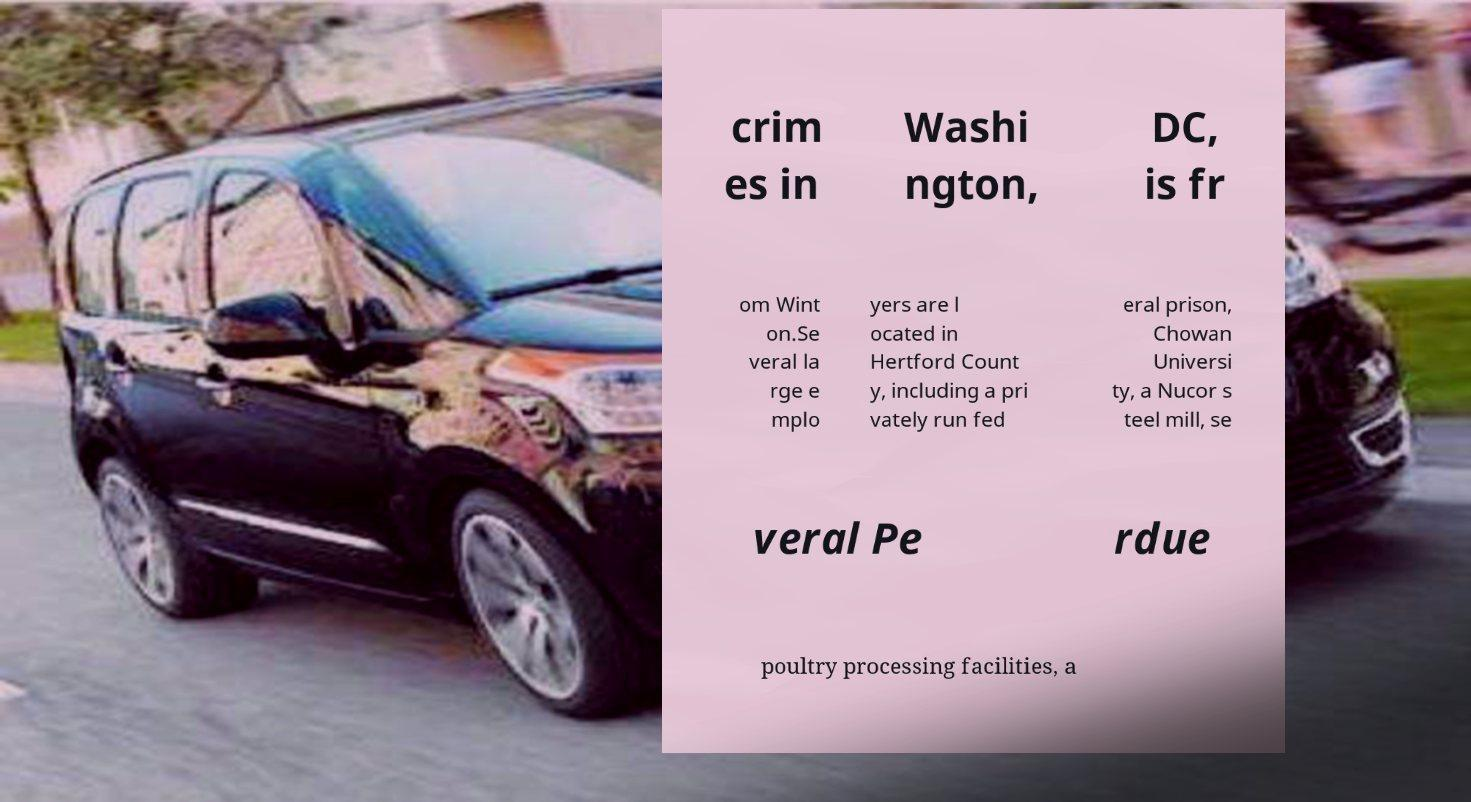Please read and relay the text visible in this image. What does it say? crim es in Washi ngton, DC, is fr om Wint on.Se veral la rge e mplo yers are l ocated in Hertford Count y, including a pri vately run fed eral prison, Chowan Universi ty, a Nucor s teel mill, se veral Pe rdue poultry processing facilities, a 